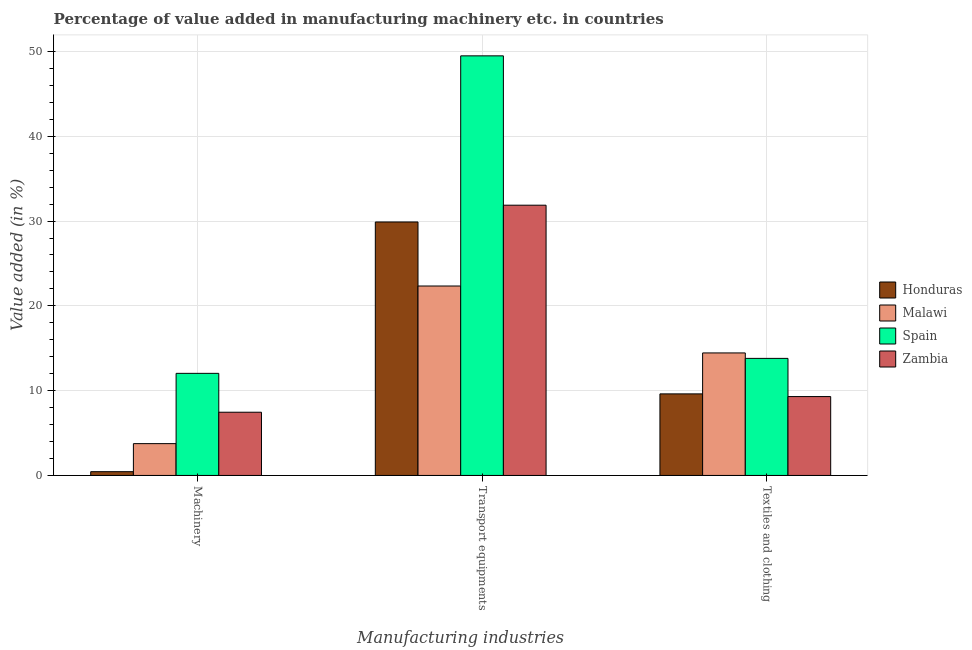Are the number of bars per tick equal to the number of legend labels?
Offer a very short reply. Yes. What is the label of the 3rd group of bars from the left?
Your answer should be very brief. Textiles and clothing. What is the value added in manufacturing textile and clothing in Honduras?
Offer a terse response. 9.62. Across all countries, what is the maximum value added in manufacturing textile and clothing?
Give a very brief answer. 14.45. Across all countries, what is the minimum value added in manufacturing textile and clothing?
Your response must be concise. 9.3. In which country was the value added in manufacturing transport equipments maximum?
Keep it short and to the point. Spain. In which country was the value added in manufacturing textile and clothing minimum?
Make the answer very short. Zambia. What is the total value added in manufacturing machinery in the graph?
Offer a very short reply. 23.69. What is the difference between the value added in manufacturing transport equipments in Spain and that in Malawi?
Provide a succinct answer. 27.14. What is the difference between the value added in manufacturing machinery in Malawi and the value added in manufacturing transport equipments in Zambia?
Ensure brevity in your answer.  -28.12. What is the average value added in manufacturing transport equipments per country?
Give a very brief answer. 33.4. What is the difference between the value added in manufacturing transport equipments and value added in manufacturing machinery in Malawi?
Provide a short and direct response. 18.59. What is the ratio of the value added in manufacturing machinery in Spain to that in Zambia?
Your response must be concise. 1.61. Is the difference between the value added in manufacturing transport equipments in Honduras and Zambia greater than the difference between the value added in manufacturing machinery in Honduras and Zambia?
Make the answer very short. Yes. What is the difference between the highest and the second highest value added in manufacturing machinery?
Give a very brief answer. 4.58. What is the difference between the highest and the lowest value added in manufacturing machinery?
Your response must be concise. 11.6. Is the sum of the value added in manufacturing machinery in Spain and Zambia greater than the maximum value added in manufacturing transport equipments across all countries?
Your answer should be very brief. No. What does the 2nd bar from the left in Machinery represents?
Your response must be concise. Malawi. Does the graph contain any zero values?
Provide a short and direct response. No. Does the graph contain grids?
Offer a terse response. Yes. What is the title of the graph?
Your answer should be compact. Percentage of value added in manufacturing machinery etc. in countries. What is the label or title of the X-axis?
Provide a short and direct response. Manufacturing industries. What is the label or title of the Y-axis?
Your response must be concise. Value added (in %). What is the Value added (in %) of Honduras in Machinery?
Your answer should be compact. 0.44. What is the Value added (in %) of Malawi in Machinery?
Ensure brevity in your answer.  3.75. What is the Value added (in %) in Spain in Machinery?
Your answer should be very brief. 12.04. What is the Value added (in %) in Zambia in Machinery?
Your response must be concise. 7.46. What is the Value added (in %) of Honduras in Transport equipments?
Your answer should be compact. 29.89. What is the Value added (in %) in Malawi in Transport equipments?
Keep it short and to the point. 22.34. What is the Value added (in %) of Spain in Transport equipments?
Keep it short and to the point. 49.49. What is the Value added (in %) of Zambia in Transport equipments?
Your response must be concise. 31.87. What is the Value added (in %) of Honduras in Textiles and clothing?
Give a very brief answer. 9.62. What is the Value added (in %) of Malawi in Textiles and clothing?
Your answer should be compact. 14.45. What is the Value added (in %) of Spain in Textiles and clothing?
Your answer should be compact. 13.81. What is the Value added (in %) in Zambia in Textiles and clothing?
Provide a succinct answer. 9.3. Across all Manufacturing industries, what is the maximum Value added (in %) of Honduras?
Keep it short and to the point. 29.89. Across all Manufacturing industries, what is the maximum Value added (in %) in Malawi?
Provide a succinct answer. 22.34. Across all Manufacturing industries, what is the maximum Value added (in %) in Spain?
Your answer should be very brief. 49.49. Across all Manufacturing industries, what is the maximum Value added (in %) of Zambia?
Provide a succinct answer. 31.87. Across all Manufacturing industries, what is the minimum Value added (in %) of Honduras?
Offer a terse response. 0.44. Across all Manufacturing industries, what is the minimum Value added (in %) in Malawi?
Give a very brief answer. 3.75. Across all Manufacturing industries, what is the minimum Value added (in %) in Spain?
Keep it short and to the point. 12.04. Across all Manufacturing industries, what is the minimum Value added (in %) of Zambia?
Keep it short and to the point. 7.46. What is the total Value added (in %) in Honduras in the graph?
Provide a short and direct response. 39.95. What is the total Value added (in %) of Malawi in the graph?
Provide a short and direct response. 40.54. What is the total Value added (in %) of Spain in the graph?
Give a very brief answer. 75.33. What is the total Value added (in %) in Zambia in the graph?
Your response must be concise. 48.63. What is the difference between the Value added (in %) of Honduras in Machinery and that in Transport equipments?
Your answer should be compact. -29.45. What is the difference between the Value added (in %) in Malawi in Machinery and that in Transport equipments?
Give a very brief answer. -18.59. What is the difference between the Value added (in %) in Spain in Machinery and that in Transport equipments?
Offer a very short reply. -37.45. What is the difference between the Value added (in %) in Zambia in Machinery and that in Transport equipments?
Your answer should be compact. -24.42. What is the difference between the Value added (in %) of Honduras in Machinery and that in Textiles and clothing?
Your answer should be very brief. -9.18. What is the difference between the Value added (in %) of Malawi in Machinery and that in Textiles and clothing?
Offer a very short reply. -10.7. What is the difference between the Value added (in %) in Spain in Machinery and that in Textiles and clothing?
Give a very brief answer. -1.77. What is the difference between the Value added (in %) of Zambia in Machinery and that in Textiles and clothing?
Your answer should be compact. -1.85. What is the difference between the Value added (in %) of Honduras in Transport equipments and that in Textiles and clothing?
Keep it short and to the point. 20.27. What is the difference between the Value added (in %) of Malawi in Transport equipments and that in Textiles and clothing?
Your answer should be compact. 7.89. What is the difference between the Value added (in %) of Spain in Transport equipments and that in Textiles and clothing?
Keep it short and to the point. 35.68. What is the difference between the Value added (in %) in Zambia in Transport equipments and that in Textiles and clothing?
Provide a succinct answer. 22.57. What is the difference between the Value added (in %) in Honduras in Machinery and the Value added (in %) in Malawi in Transport equipments?
Provide a succinct answer. -21.9. What is the difference between the Value added (in %) in Honduras in Machinery and the Value added (in %) in Spain in Transport equipments?
Provide a succinct answer. -49.04. What is the difference between the Value added (in %) in Honduras in Machinery and the Value added (in %) in Zambia in Transport equipments?
Your response must be concise. -31.43. What is the difference between the Value added (in %) of Malawi in Machinery and the Value added (in %) of Spain in Transport equipments?
Offer a terse response. -45.73. What is the difference between the Value added (in %) in Malawi in Machinery and the Value added (in %) in Zambia in Transport equipments?
Make the answer very short. -28.12. What is the difference between the Value added (in %) in Spain in Machinery and the Value added (in %) in Zambia in Transport equipments?
Provide a succinct answer. -19.83. What is the difference between the Value added (in %) of Honduras in Machinery and the Value added (in %) of Malawi in Textiles and clothing?
Your answer should be very brief. -14.01. What is the difference between the Value added (in %) in Honduras in Machinery and the Value added (in %) in Spain in Textiles and clothing?
Your answer should be very brief. -13.36. What is the difference between the Value added (in %) in Honduras in Machinery and the Value added (in %) in Zambia in Textiles and clothing?
Your answer should be compact. -8.86. What is the difference between the Value added (in %) of Malawi in Machinery and the Value added (in %) of Spain in Textiles and clothing?
Ensure brevity in your answer.  -10.05. What is the difference between the Value added (in %) of Malawi in Machinery and the Value added (in %) of Zambia in Textiles and clothing?
Keep it short and to the point. -5.55. What is the difference between the Value added (in %) of Spain in Machinery and the Value added (in %) of Zambia in Textiles and clothing?
Give a very brief answer. 2.74. What is the difference between the Value added (in %) of Honduras in Transport equipments and the Value added (in %) of Malawi in Textiles and clothing?
Provide a short and direct response. 15.44. What is the difference between the Value added (in %) in Honduras in Transport equipments and the Value added (in %) in Spain in Textiles and clothing?
Ensure brevity in your answer.  16.09. What is the difference between the Value added (in %) of Honduras in Transport equipments and the Value added (in %) of Zambia in Textiles and clothing?
Keep it short and to the point. 20.59. What is the difference between the Value added (in %) of Malawi in Transport equipments and the Value added (in %) of Spain in Textiles and clothing?
Make the answer very short. 8.54. What is the difference between the Value added (in %) of Malawi in Transport equipments and the Value added (in %) of Zambia in Textiles and clothing?
Your response must be concise. 13.04. What is the difference between the Value added (in %) of Spain in Transport equipments and the Value added (in %) of Zambia in Textiles and clothing?
Ensure brevity in your answer.  40.18. What is the average Value added (in %) of Honduras per Manufacturing industries?
Offer a terse response. 13.32. What is the average Value added (in %) in Malawi per Manufacturing industries?
Make the answer very short. 13.51. What is the average Value added (in %) in Spain per Manufacturing industries?
Your answer should be compact. 25.11. What is the average Value added (in %) of Zambia per Manufacturing industries?
Your response must be concise. 16.21. What is the difference between the Value added (in %) in Honduras and Value added (in %) in Malawi in Machinery?
Make the answer very short. -3.31. What is the difference between the Value added (in %) of Honduras and Value added (in %) of Spain in Machinery?
Offer a very short reply. -11.6. What is the difference between the Value added (in %) of Honduras and Value added (in %) of Zambia in Machinery?
Keep it short and to the point. -7.01. What is the difference between the Value added (in %) of Malawi and Value added (in %) of Spain in Machinery?
Keep it short and to the point. -8.29. What is the difference between the Value added (in %) in Malawi and Value added (in %) in Zambia in Machinery?
Your response must be concise. -3.7. What is the difference between the Value added (in %) of Spain and Value added (in %) of Zambia in Machinery?
Offer a very short reply. 4.58. What is the difference between the Value added (in %) in Honduras and Value added (in %) in Malawi in Transport equipments?
Give a very brief answer. 7.55. What is the difference between the Value added (in %) of Honduras and Value added (in %) of Spain in Transport equipments?
Make the answer very short. -19.59. What is the difference between the Value added (in %) in Honduras and Value added (in %) in Zambia in Transport equipments?
Your response must be concise. -1.98. What is the difference between the Value added (in %) in Malawi and Value added (in %) in Spain in Transport equipments?
Provide a succinct answer. -27.14. What is the difference between the Value added (in %) of Malawi and Value added (in %) of Zambia in Transport equipments?
Your response must be concise. -9.53. What is the difference between the Value added (in %) in Spain and Value added (in %) in Zambia in Transport equipments?
Your answer should be very brief. 17.61. What is the difference between the Value added (in %) of Honduras and Value added (in %) of Malawi in Textiles and clothing?
Keep it short and to the point. -4.83. What is the difference between the Value added (in %) of Honduras and Value added (in %) of Spain in Textiles and clothing?
Give a very brief answer. -4.19. What is the difference between the Value added (in %) of Honduras and Value added (in %) of Zambia in Textiles and clothing?
Provide a succinct answer. 0.32. What is the difference between the Value added (in %) in Malawi and Value added (in %) in Spain in Textiles and clothing?
Offer a very short reply. 0.64. What is the difference between the Value added (in %) in Malawi and Value added (in %) in Zambia in Textiles and clothing?
Provide a succinct answer. 5.15. What is the difference between the Value added (in %) in Spain and Value added (in %) in Zambia in Textiles and clothing?
Keep it short and to the point. 4.5. What is the ratio of the Value added (in %) of Honduras in Machinery to that in Transport equipments?
Offer a very short reply. 0.01. What is the ratio of the Value added (in %) in Malawi in Machinery to that in Transport equipments?
Offer a very short reply. 0.17. What is the ratio of the Value added (in %) of Spain in Machinery to that in Transport equipments?
Keep it short and to the point. 0.24. What is the ratio of the Value added (in %) in Zambia in Machinery to that in Transport equipments?
Provide a succinct answer. 0.23. What is the ratio of the Value added (in %) in Honduras in Machinery to that in Textiles and clothing?
Offer a very short reply. 0.05. What is the ratio of the Value added (in %) of Malawi in Machinery to that in Textiles and clothing?
Ensure brevity in your answer.  0.26. What is the ratio of the Value added (in %) of Spain in Machinery to that in Textiles and clothing?
Your response must be concise. 0.87. What is the ratio of the Value added (in %) of Zambia in Machinery to that in Textiles and clothing?
Your response must be concise. 0.8. What is the ratio of the Value added (in %) of Honduras in Transport equipments to that in Textiles and clothing?
Keep it short and to the point. 3.11. What is the ratio of the Value added (in %) of Malawi in Transport equipments to that in Textiles and clothing?
Offer a terse response. 1.55. What is the ratio of the Value added (in %) in Spain in Transport equipments to that in Textiles and clothing?
Offer a terse response. 3.58. What is the ratio of the Value added (in %) of Zambia in Transport equipments to that in Textiles and clothing?
Offer a very short reply. 3.43. What is the difference between the highest and the second highest Value added (in %) of Honduras?
Make the answer very short. 20.27. What is the difference between the highest and the second highest Value added (in %) of Malawi?
Ensure brevity in your answer.  7.89. What is the difference between the highest and the second highest Value added (in %) in Spain?
Keep it short and to the point. 35.68. What is the difference between the highest and the second highest Value added (in %) of Zambia?
Ensure brevity in your answer.  22.57. What is the difference between the highest and the lowest Value added (in %) in Honduras?
Give a very brief answer. 29.45. What is the difference between the highest and the lowest Value added (in %) of Malawi?
Provide a succinct answer. 18.59. What is the difference between the highest and the lowest Value added (in %) in Spain?
Your answer should be compact. 37.45. What is the difference between the highest and the lowest Value added (in %) in Zambia?
Ensure brevity in your answer.  24.42. 